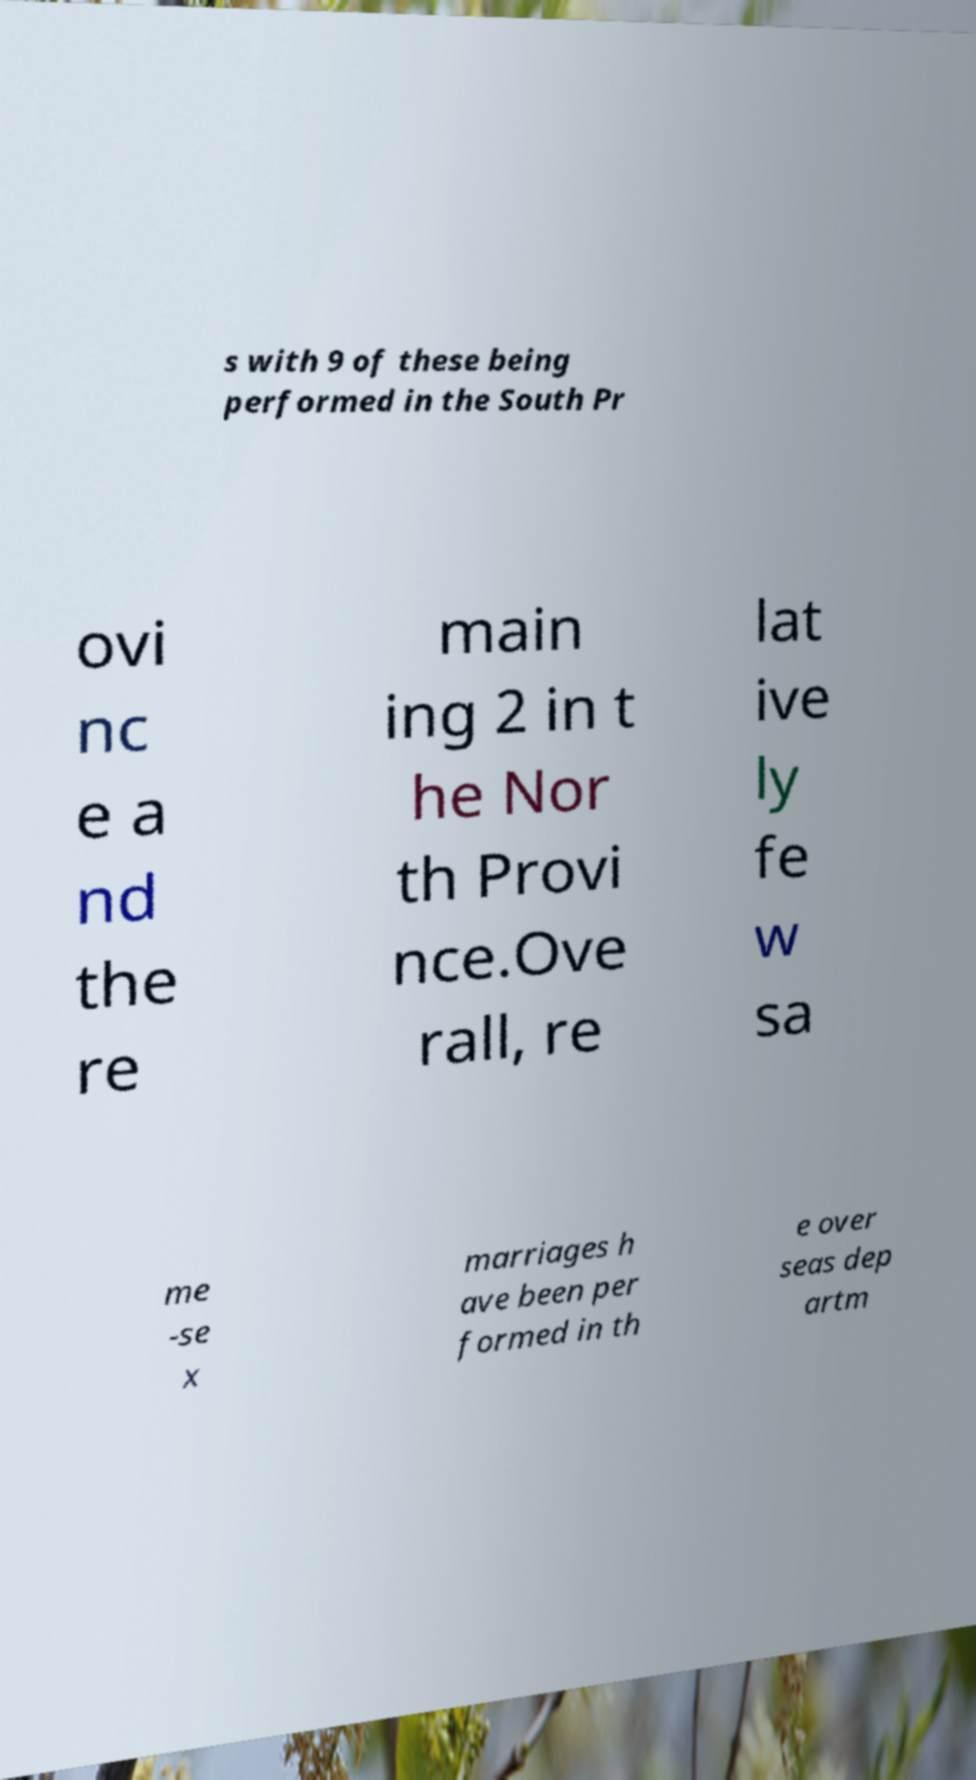What messages or text are displayed in this image? I need them in a readable, typed format. s with 9 of these being performed in the South Pr ovi nc e a nd the re main ing 2 in t he Nor th Provi nce.Ove rall, re lat ive ly fe w sa me -se x marriages h ave been per formed in th e over seas dep artm 